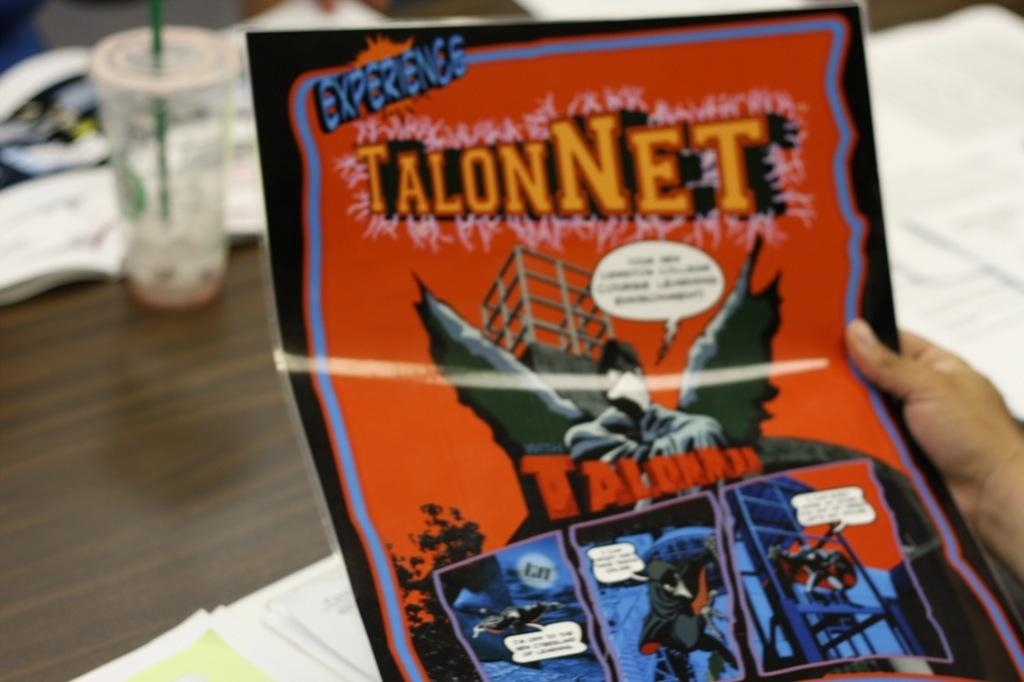<image>
Create a compact narrative representing the image presented. A hand holding a flyer that says TalonNet 